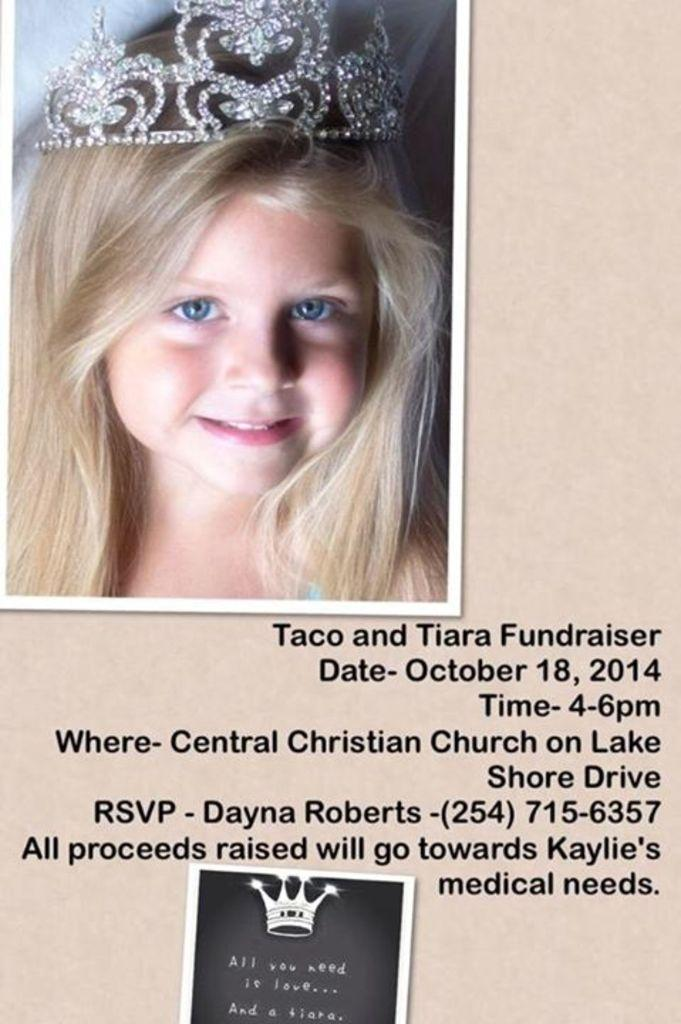Where is the girl located in the image? The girl is in the top left corner of the image. What is the girl wearing on her head? The girl is wearing a crown. What can be found at the bottom of the image? There is text at the bottom of the image. What type of gun is the girl holding in the image? There is no gun present in the image; the girl is wearing a crown and there is text at the bottom of the image. 